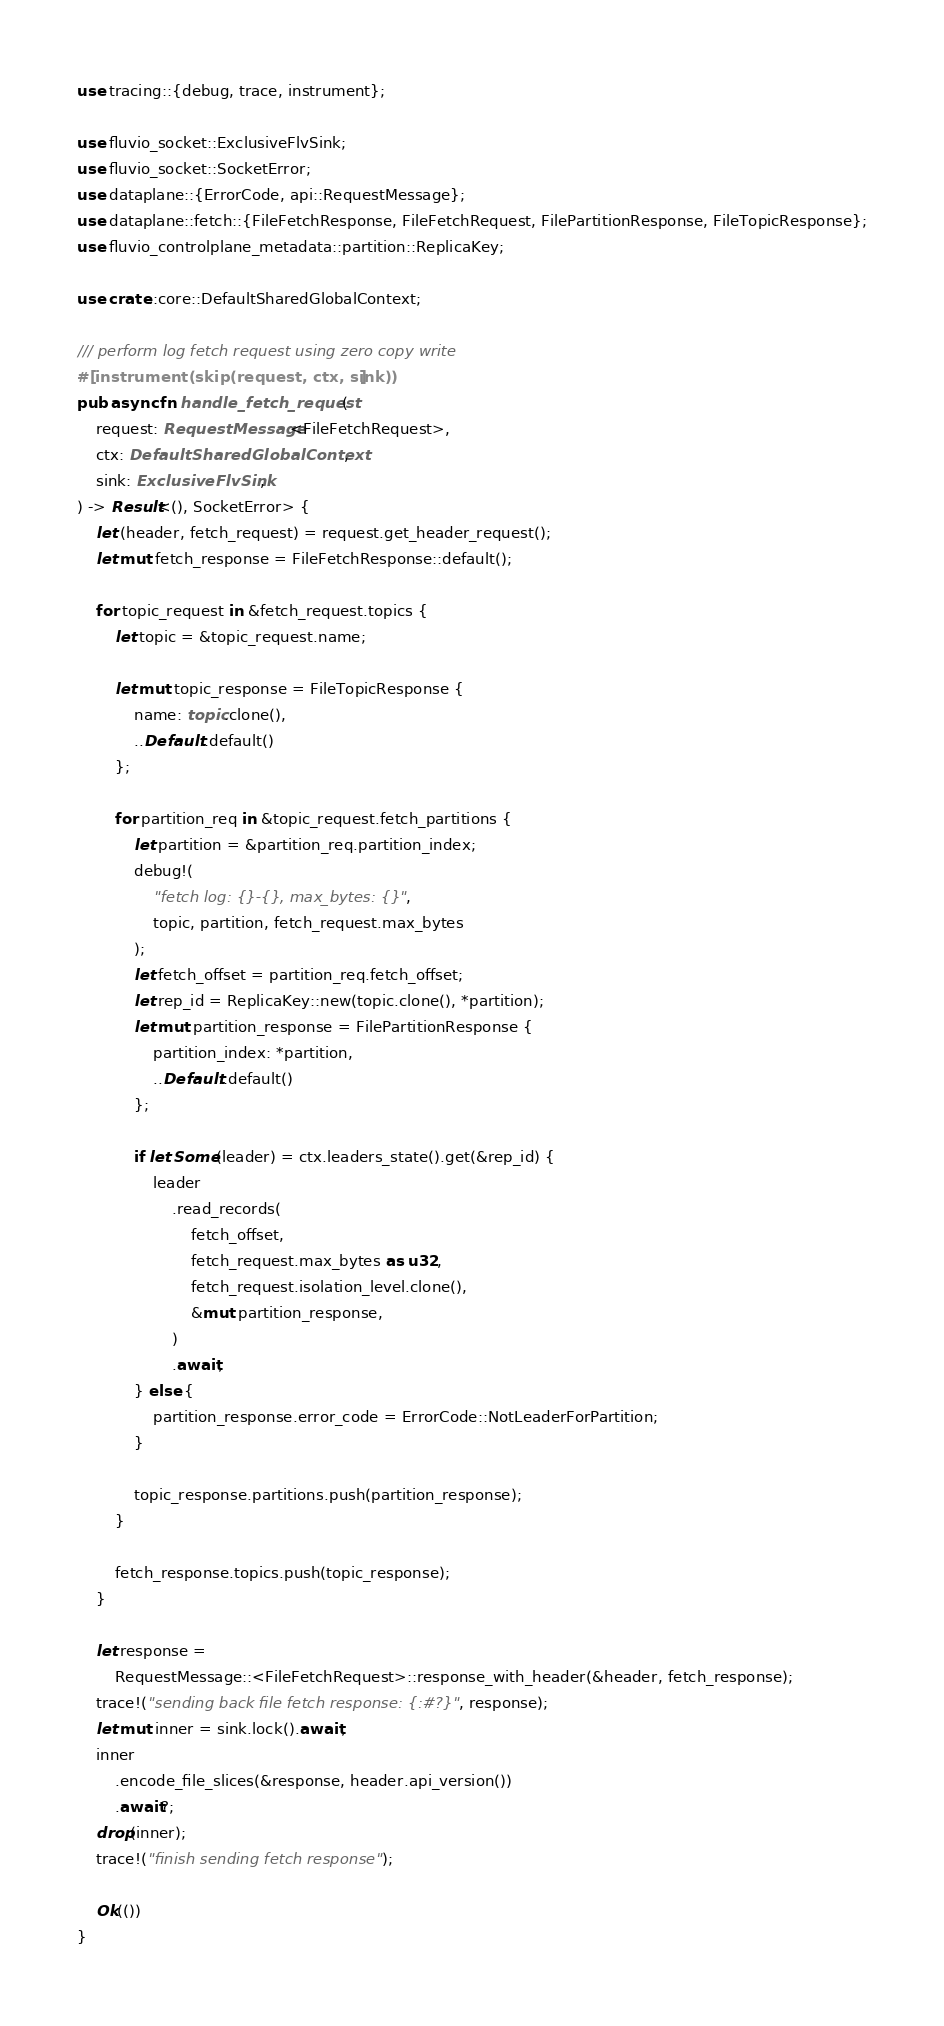<code> <loc_0><loc_0><loc_500><loc_500><_Rust_>use tracing::{debug, trace, instrument};

use fluvio_socket::ExclusiveFlvSink;
use fluvio_socket::SocketError;
use dataplane::{ErrorCode, api::RequestMessage};
use dataplane::fetch::{FileFetchResponse, FileFetchRequest, FilePartitionResponse, FileTopicResponse};
use fluvio_controlplane_metadata::partition::ReplicaKey;

use crate::core::DefaultSharedGlobalContext;

/// perform log fetch request using zero copy write
#[instrument(skip(request, ctx, sink))]
pub async fn handle_fetch_request(
    request: RequestMessage<FileFetchRequest>,
    ctx: DefaultSharedGlobalContext,
    sink: ExclusiveFlvSink,
) -> Result<(), SocketError> {
    let (header, fetch_request) = request.get_header_request();
    let mut fetch_response = FileFetchResponse::default();

    for topic_request in &fetch_request.topics {
        let topic = &topic_request.name;

        let mut topic_response = FileTopicResponse {
            name: topic.clone(),
            ..Default::default()
        };

        for partition_req in &topic_request.fetch_partitions {
            let partition = &partition_req.partition_index;
            debug!(
                "fetch log: {}-{}, max_bytes: {}",
                topic, partition, fetch_request.max_bytes
            );
            let fetch_offset = partition_req.fetch_offset;
            let rep_id = ReplicaKey::new(topic.clone(), *partition);
            let mut partition_response = FilePartitionResponse {
                partition_index: *partition,
                ..Default::default()
            };

            if let Some(leader) = ctx.leaders_state().get(&rep_id) {
                leader
                    .read_records(
                        fetch_offset,
                        fetch_request.max_bytes as u32,
                        fetch_request.isolation_level.clone(),
                        &mut partition_response,
                    )
                    .await;
            } else {
                partition_response.error_code = ErrorCode::NotLeaderForPartition;
            }

            topic_response.partitions.push(partition_response);
        }

        fetch_response.topics.push(topic_response);
    }

    let response =
        RequestMessage::<FileFetchRequest>::response_with_header(&header, fetch_response);
    trace!("sending back file fetch response: {:#?}", response);
    let mut inner = sink.lock().await;
    inner
        .encode_file_slices(&response, header.api_version())
        .await?;
    drop(inner);
    trace!("finish sending fetch response");

    Ok(())
}
</code> 